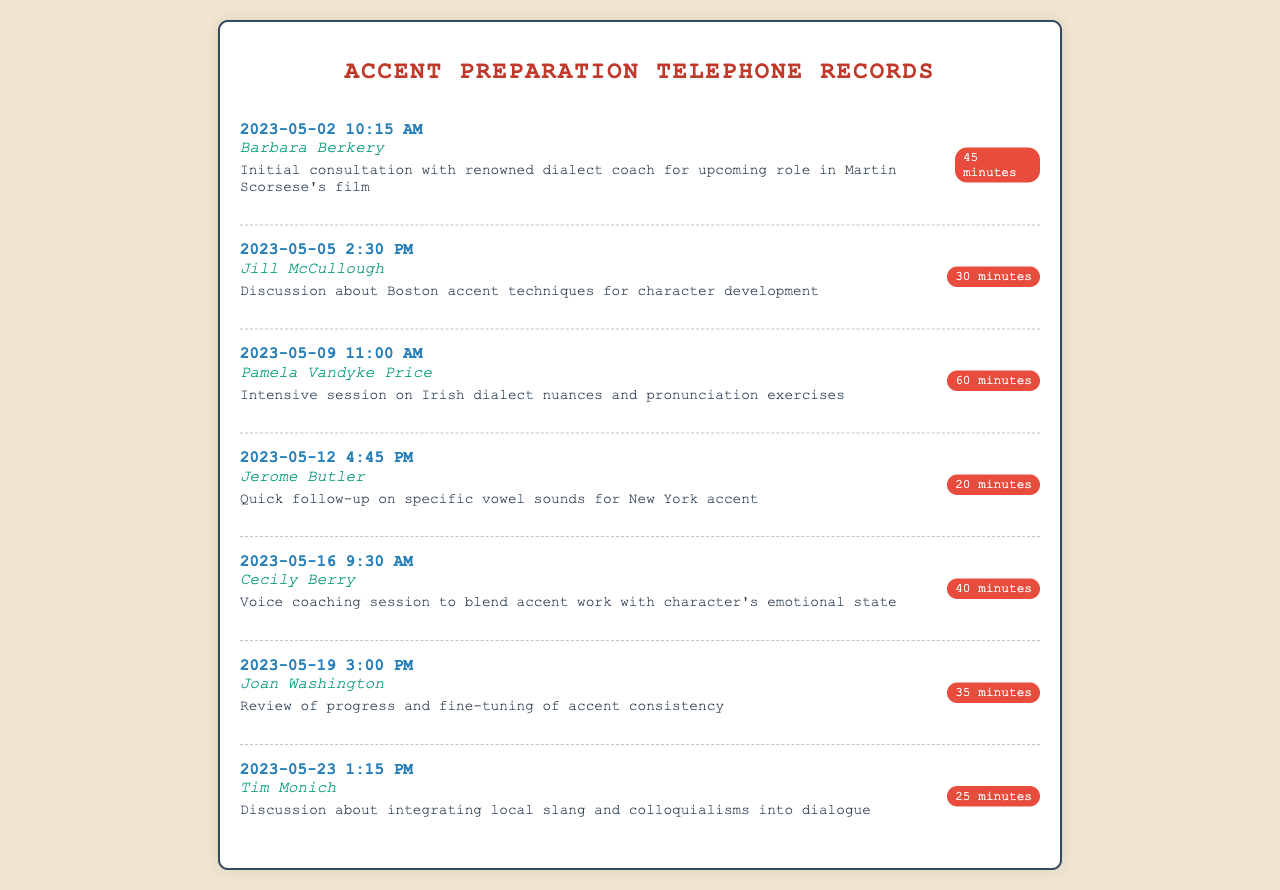what is the date of the first call? The first call was made on May 2, 2023.
Answer: May 2, 2023 who was the dialect coach contacted for the Irish dialect session? The dialect coach for the Irish dialect session was Pamela Vandyke Price.
Answer: Pamela Vandyke Price how long was the session with Joan Washington? The session with Joan Washington lasted for 35 minutes.
Answer: 35 minutes which director's film is mentioned in the initial consultation? The film mentioned in the initial consultation is directed by Martin Scorsese.
Answer: Martin Scorsese what was discussed during the call with Tim Monich? The discussion during the call with Tim Monich was about integrating local slang and colloquialisms.
Answer: integrating local slang and colloquialisms how many dialect coaches were contacted in total? There were 7 different dialect coaches contacted.
Answer: 7 when was the last call made? The last call was made on May 23, 2023.
Answer: May 23, 2023 what was the purpose of the call with Cecily Berry? The purpose of the call with Cecily Berry was for a voice coaching session.
Answer: voice coaching session 